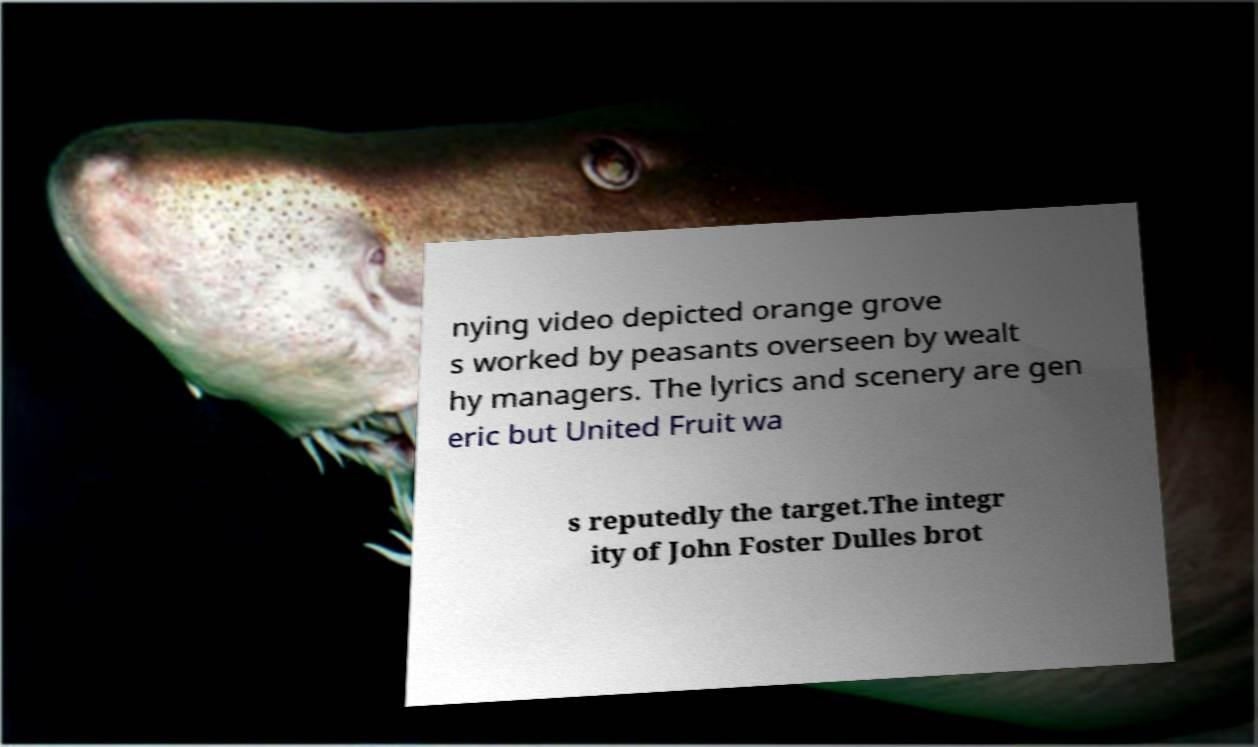What messages or text are displayed in this image? I need them in a readable, typed format. nying video depicted orange grove s worked by peasants overseen by wealt hy managers. The lyrics and scenery are gen eric but United Fruit wa s reputedly the target.The integr ity of John Foster Dulles brot 